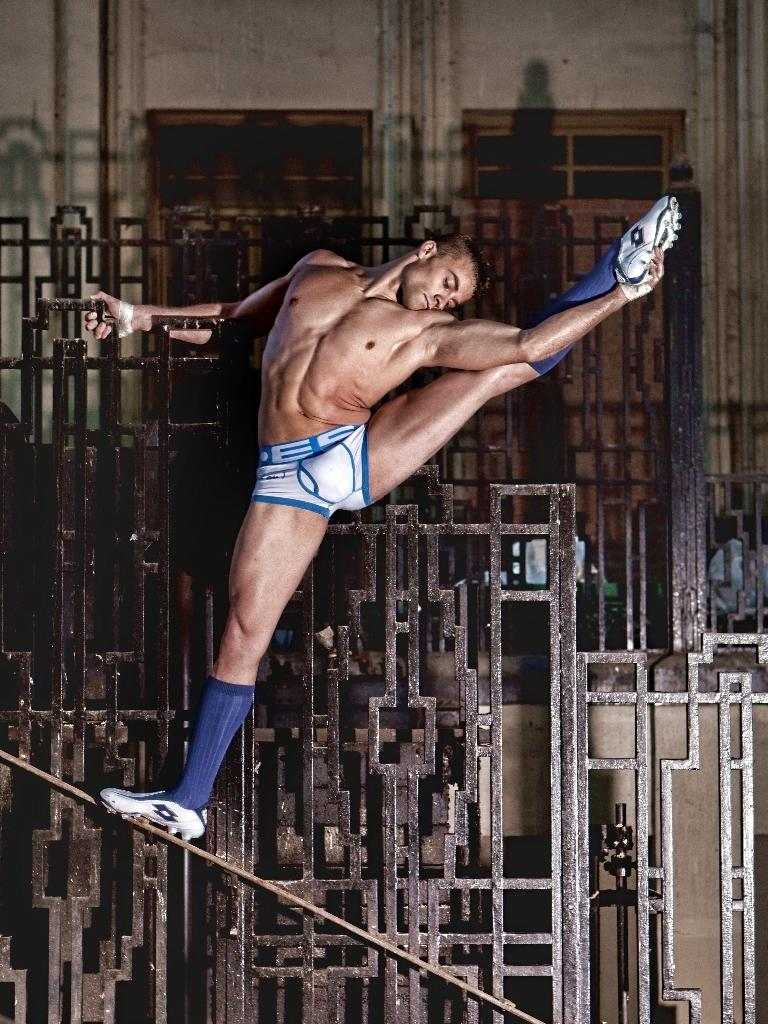What is the man doing in the image? The man is standing on a rod in the image. What can be seen in the background of the image? There are metal rods visible in the background of the image. What is the man standing on? The man is standing on a rod. What is the purpose of the rods in the image? The purpose of the rods is not explicitly stated in the image, but they may be used for support or as part of a structure. What type of curve can be seen in the zinc structure in the image? There is no zinc structure or curve present in the image. 